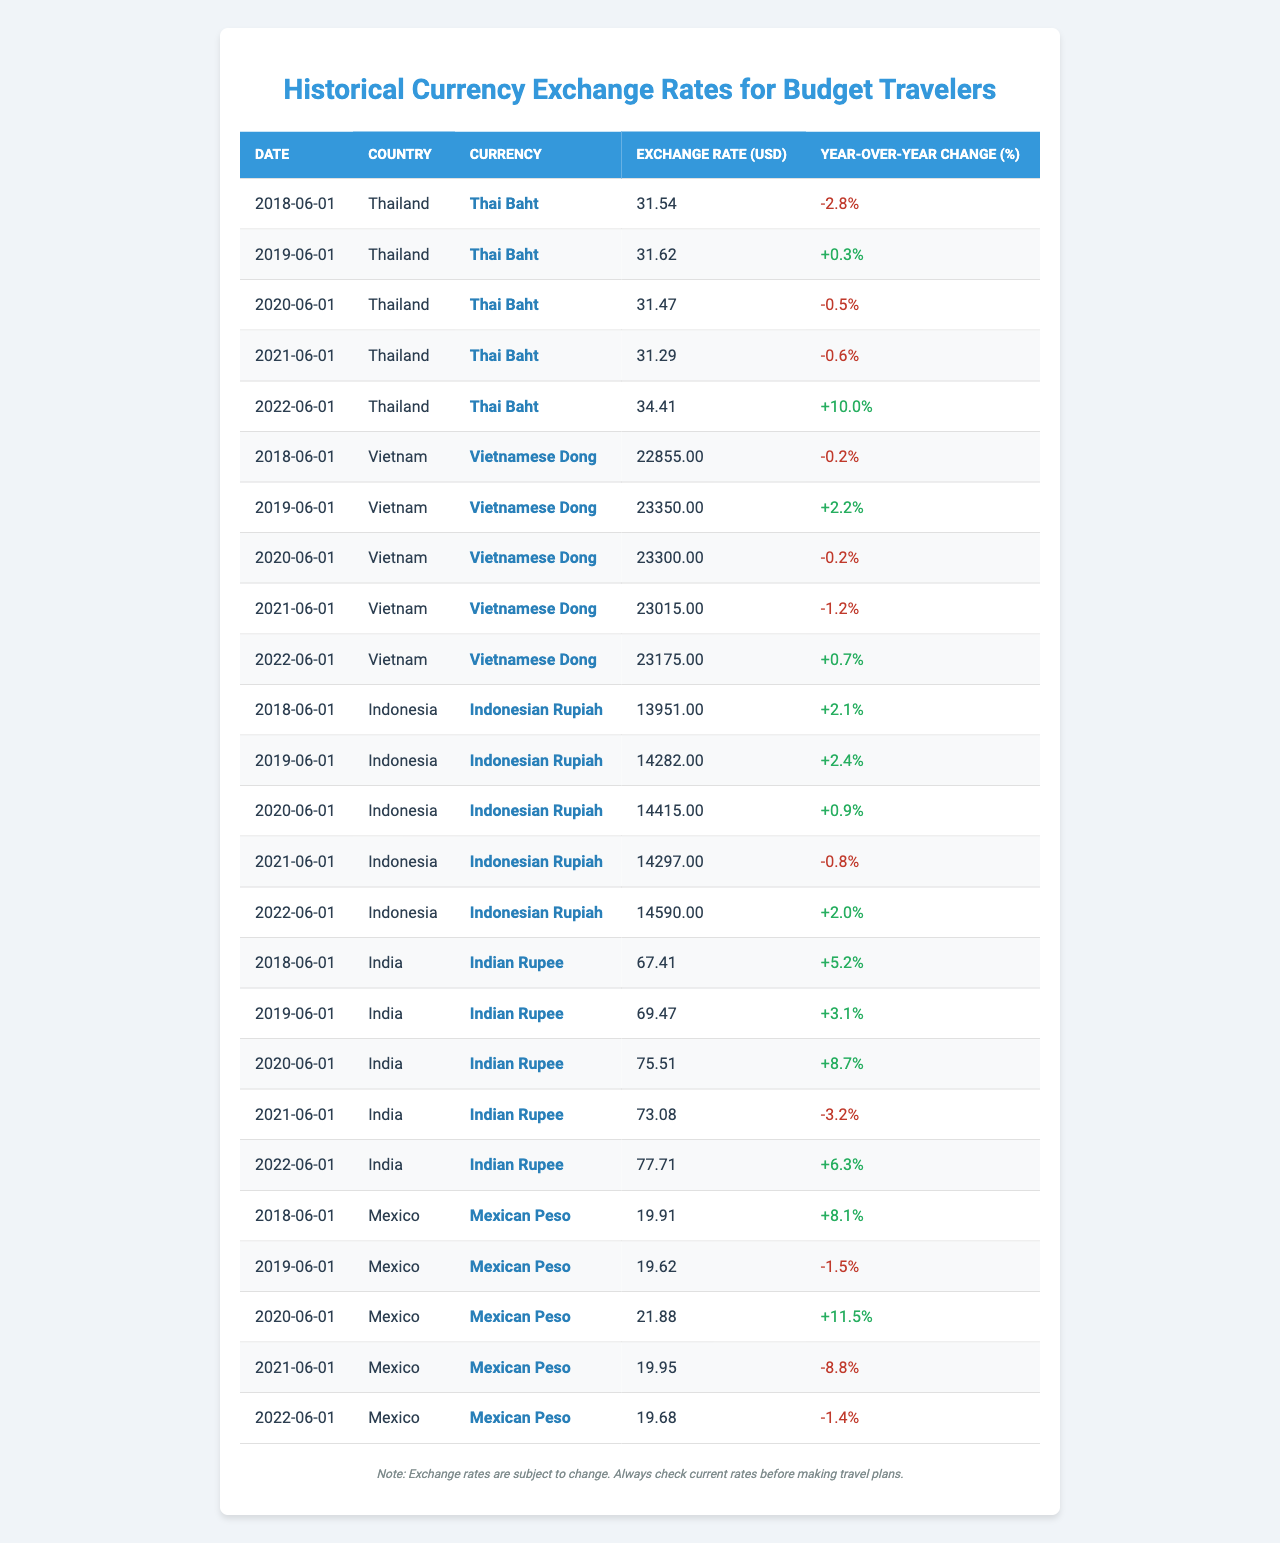What was the exchange rate for the Thai Baht on June 1, 2022? Looking at the table, the row that corresponds to Thailand on June 1, 2022, shows an exchange rate of 34.41 for the Thai Baht.
Answer: 34.41 Which country had the highest exchange rate in 2020? By reviewing the table for the year 2020, the highest exchange rate is for the Mexican Peso at 21.88.
Answer: Mexico What was the year-over-year change in the exchange rate for the Indian Rupee in 2021? The entry for India on June 1, 2021, shows a year-over-year change of -3.2%.
Answer: -3.2% Which currency had a consistent increase in exchange rates from 2018 to 2022? Upon examining the data, the Indonesian Rupiah experienced an increase from 13951 in 2018 to 14590 in 2022, indicating a consistent increase over the period.
Answer: Indonesian Rupiah What was the average exchange rate for the Vietnamese Dong over the five years? Adding the exchange rates of the Vietnamese Dong (22855, 23350, 23300, 23015, and 23175) gives 115095. Dividing by 5 results in an average of 23019.
Answer: 23019 Did the Mexican Peso have a positive year-over-year change in 2022? According to the table, the Mexican Peso had a year-over-year change of -1.4% in 2022, which is negative.
Answer: No Which currency had the greatest year-over-year increase in 2022 and by how much? The currency that had the greatest year-over-year increase in 2022 was the Thai Baht, with an increase of 10.0%.
Answer: Thai Baht, 10.0% What was the total change in exchange rate for the Indian Rupee from 2018 to 2022? The exchange rates for the Indian Rupee are 67.41 in 2018 and 77.71 in 2022. The total change is 77.71 - 67.41 = 10.30.
Answer: 10.30 Which year saw the lowest exchange rate for the Thai Baht in the data presented? By examining the exchange rates for Thailand from 2018 to 2022, the lowest exchange rate recorded was in 2021 at 31.29.
Answer: 2021 What is the overall trend in exchange rates from 2018 to 2022 for Indonesia? From the values (13951, 14282, 14415, 14297, 14590), the exchange rates show an upward trend from 2018 to 2022, with minor fluctuations in between.
Answer: Upward trend 